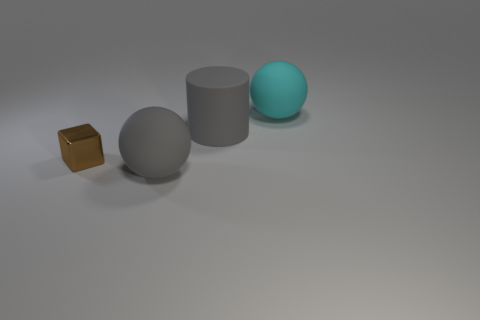There is a rubber object that is the same color as the large rubber cylinder; what is its shape?
Your answer should be very brief. Sphere. What number of things are things that are in front of the tiny brown metallic cube or large objects in front of the brown block?
Make the answer very short. 1. There is a big ball that is to the left of the big gray cylinder; is its color the same as the large cylinder that is left of the cyan object?
Your answer should be very brief. Yes. What is the shape of the thing that is both right of the block and on the left side of the large gray rubber cylinder?
Your response must be concise. Sphere. The other sphere that is the same size as the gray rubber sphere is what color?
Provide a succinct answer. Cyan. Are there any objects that have the same color as the big matte cylinder?
Your response must be concise. Yes. There is a cyan ball that is right of the brown metallic object; is it the same size as the gray object that is in front of the brown metal block?
Provide a short and direct response. Yes. What is the thing that is both behind the large gray sphere and in front of the large gray cylinder made of?
Offer a very short reply. Metal. What size is the rubber sphere that is the same color as the matte cylinder?
Make the answer very short. Large. How many other things are there of the same size as the brown metallic thing?
Your answer should be compact. 0. 